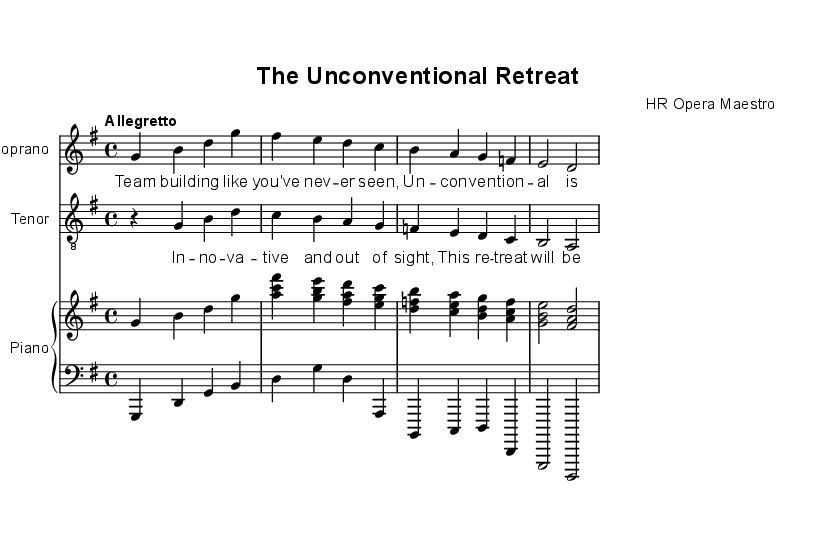What is the key signature of this music? The key signature is G major, which has one sharp (F#). This can be determined by looking at the key signature notation at the beginning of the staff.
Answer: G major What is the time signature of this piece? The time signature is 4/4, indicated at the beginning of the score. This means there are four beats in each measure and a quarter note receives one beat.
Answer: 4/4 What is the tempo marking for this piece? The tempo marking is "Allegretto," which is indicated at the beginning of the score. Allegretto suggests a moderately fast tempo, typically slower than allegro but faster than andante.
Answer: Allegretto How many measures are in the soprano part? The soprano part consists of four measures. This can be counted by identifying the vertical bar lines that separate each measure in the staff notation.
Answer: Four What type of voice is featured in the tenor part? The tenor part features a "treble_8" clef, which designates it as an octave higher than the standard treble clef. This helps indicate the vocal range appropriate for a tenor singer.
Answer: Treble 8 What is the overall theme of this opera? The theme of this opera revolves around HR professionals organizing unconventional corporate retreats, as suggested by the lyrics and the title of the piece. This theme showcases innovative team-building activities.
Answer: Team building 